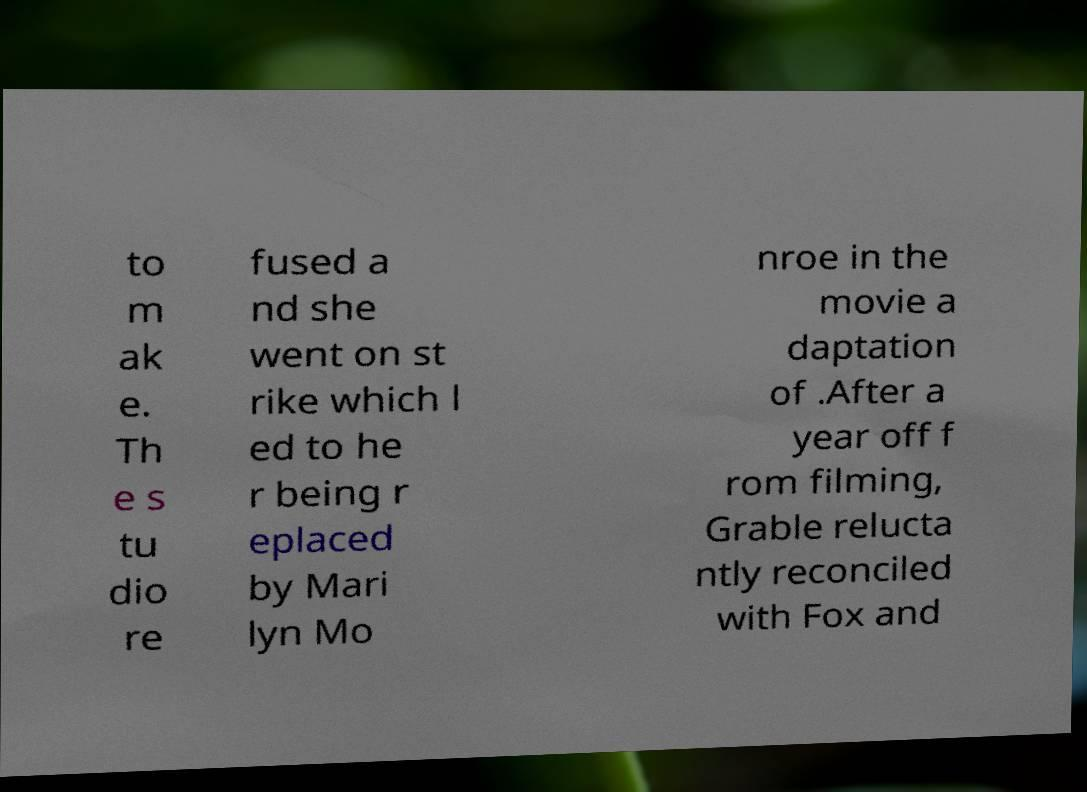Could you extract and type out the text from this image? to m ak e. Th e s tu dio re fused a nd she went on st rike which l ed to he r being r eplaced by Mari lyn Mo nroe in the movie a daptation of .After a year off f rom filming, Grable relucta ntly reconciled with Fox and 